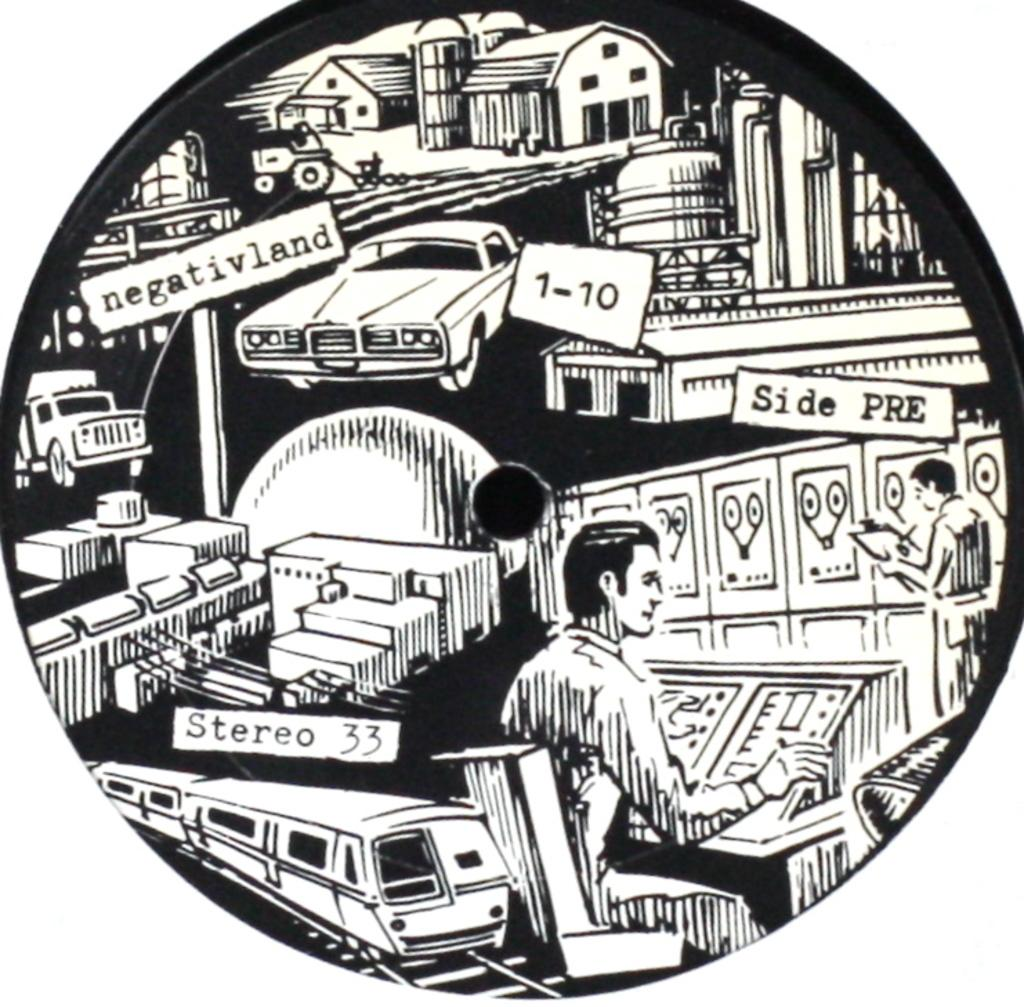What is the main subject of the drawing in the image? There is a drawing of a car in the image. What other vehicles are present in the drawing? There is a train and a truck in the drawing. Are there any buildings depicted in the drawing? Yes, there are houses in the drawing. How many people are in the drawing? There are two people in the drawing. What type of transportation infrastructure is present in the drawing? There is a railway track in the drawing. Where is the prison located in the drawing? There is no prison present in the drawing; it features a car, houses, people, a train, a truck, and a railway track. Can you tell me how many tomatoes are in the drawing? There are no tomatoes present in the drawing. 